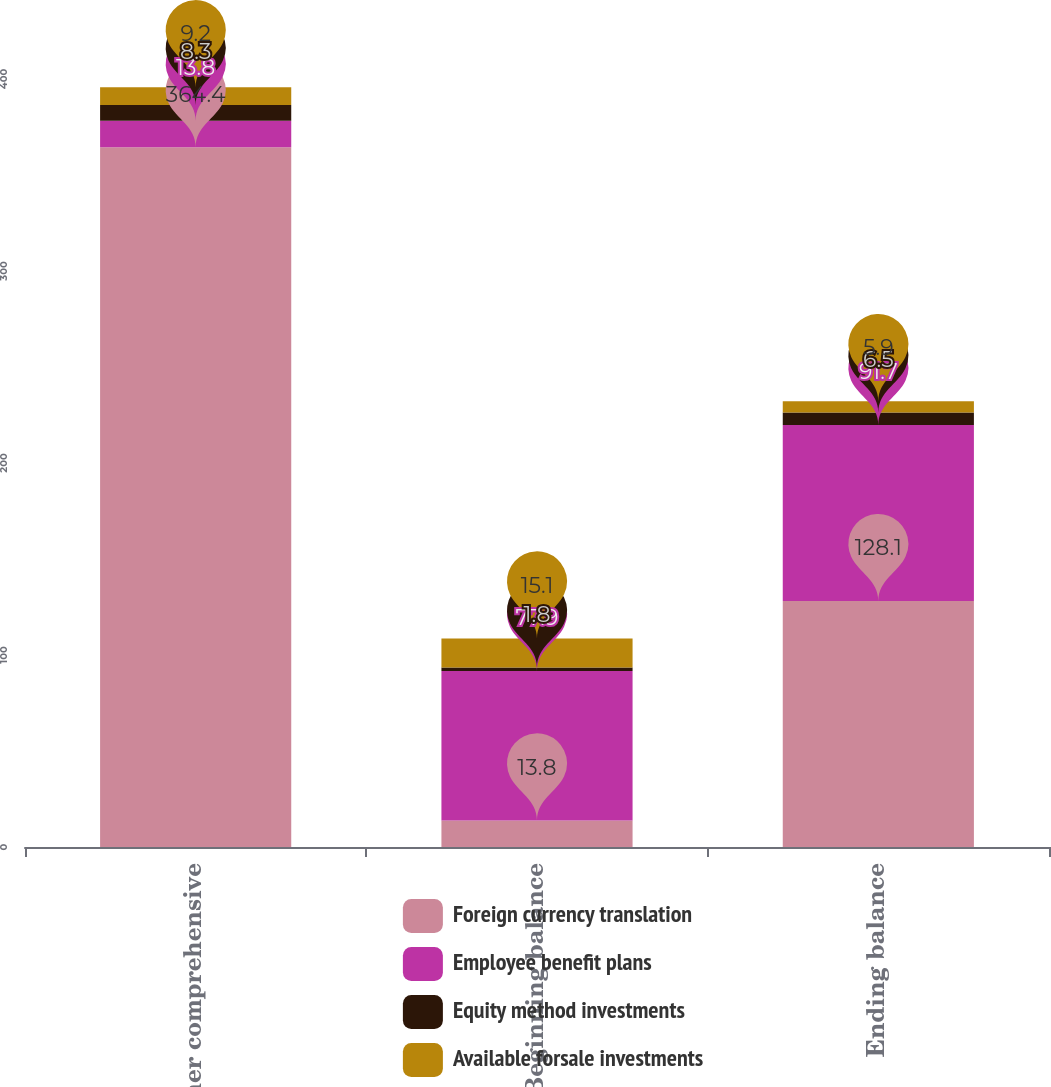Convert chart. <chart><loc_0><loc_0><loc_500><loc_500><stacked_bar_chart><ecel><fcel>Other comprehensive<fcel>Beginning balance<fcel>Ending balance<nl><fcel>Foreign currency translation<fcel>364.4<fcel>13.8<fcel>128.1<nl><fcel>Employee benefit plans<fcel>13.8<fcel>77.9<fcel>91.7<nl><fcel>Equity method investments<fcel>8.3<fcel>1.8<fcel>6.5<nl><fcel>Available forsale investments<fcel>9.2<fcel>15.1<fcel>5.9<nl></chart> 